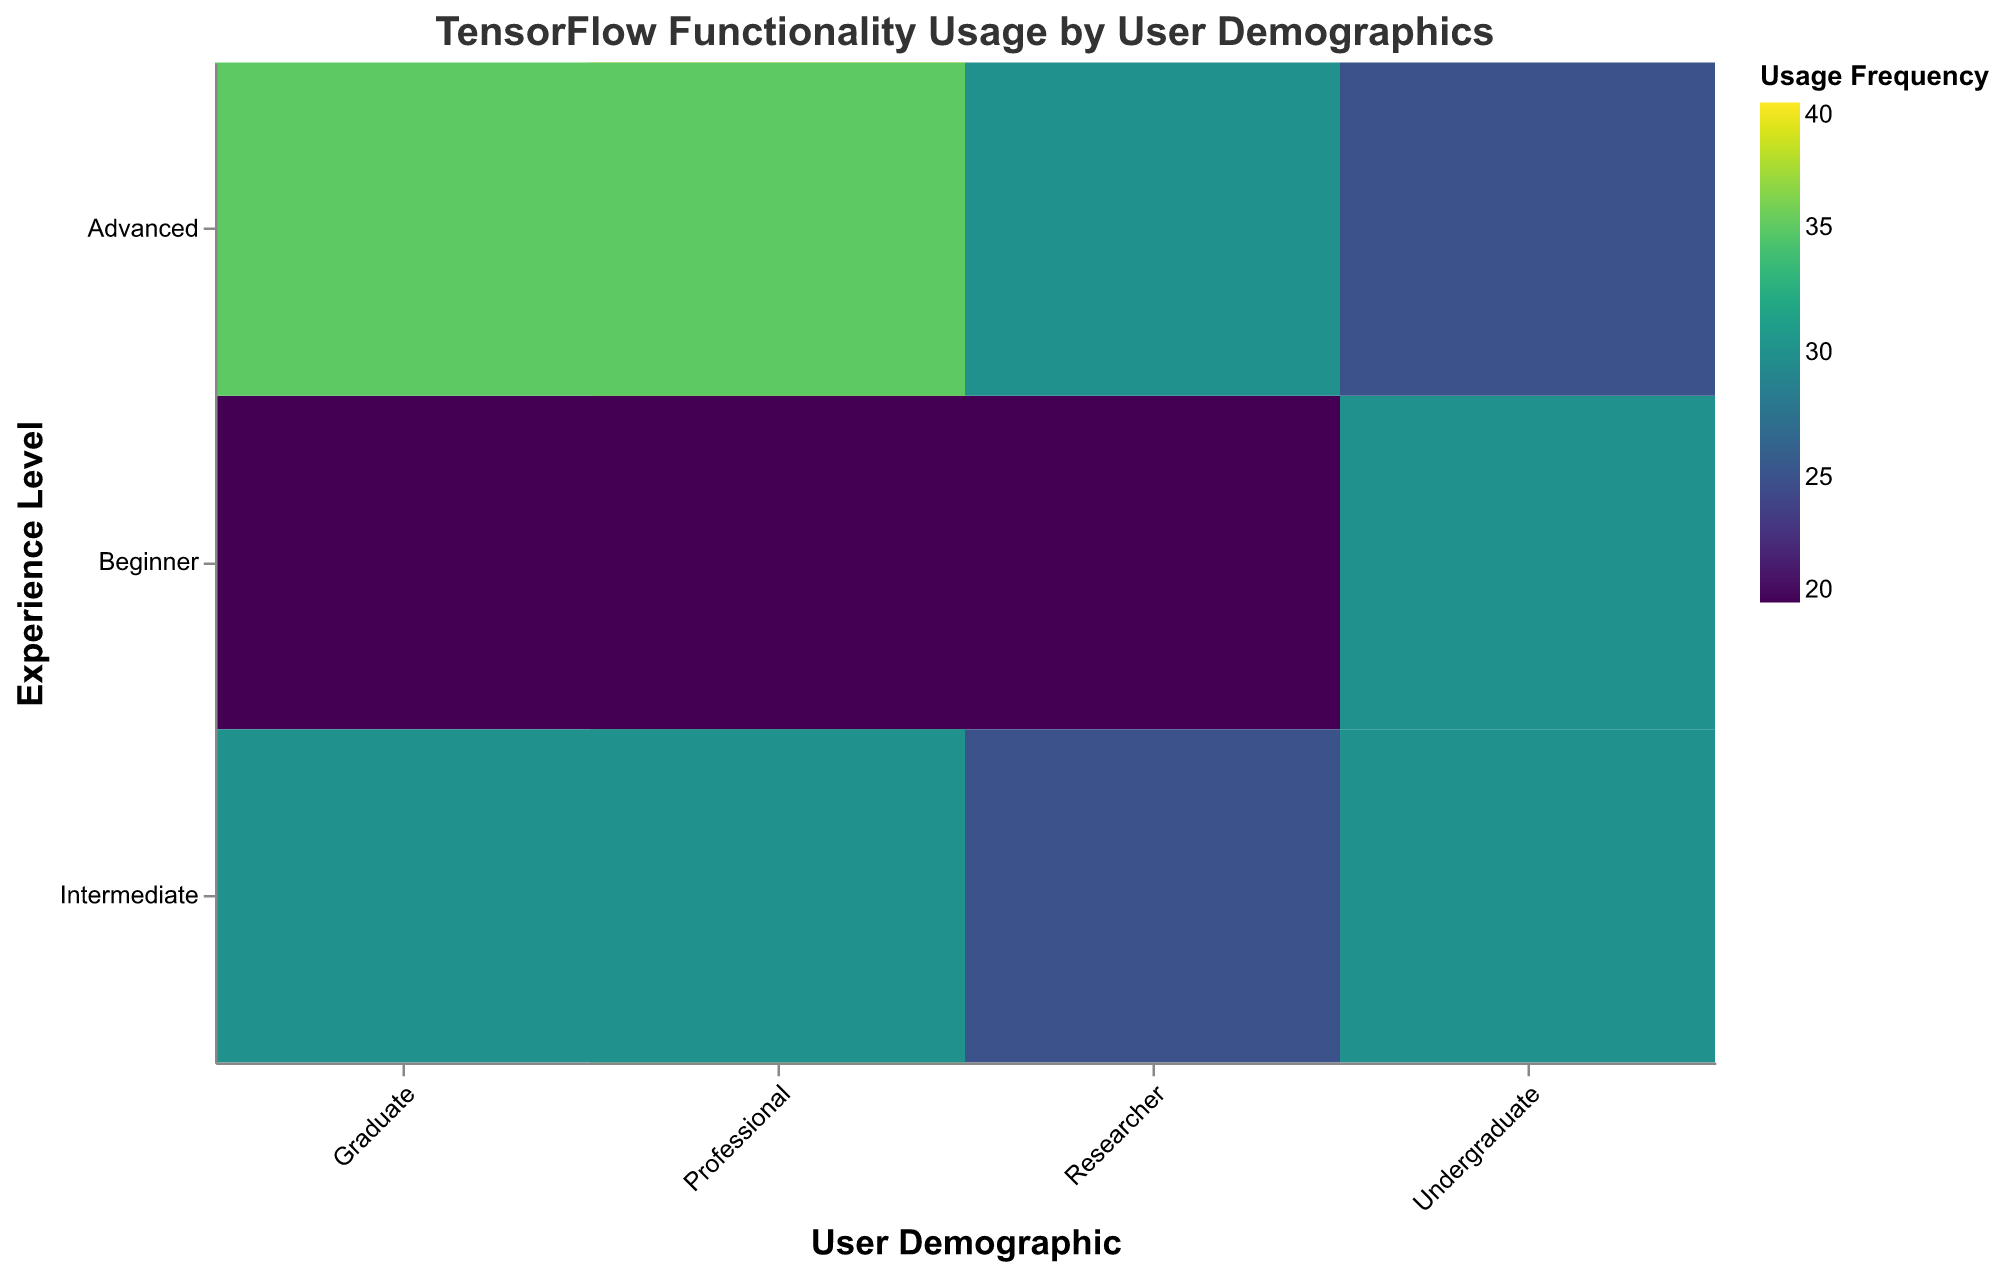What does the title of the heatmap indicate? The title of the heatmap is "TensorFlow Functionality Usage by User Demographics", which indicates that the heatmap visualizes how different functionalities and APIs of TensorFlow are used by various user groups categorized by demographics, experience levels, and project types.
Answer: TensorFlow Functionality Usage by User Demographics Which user demographic and experience level has the highest usage frequency for "Data Loading and Preprocessing"? The color intensity in the heatmap for "Data Loading and Preprocessing" is highest for "Professional" users with "Advanced" experience. This corresponds to the value of 40.
Answer: Professional, Advanced Compare the usage frequency of "Model Training" between "Graduate Advanced NLP Sentiment Analysis" and "Undergraduate Advanced Image Classification". By looking at the tooltip and color gradients in the heatmap, "Graduate Advanced NLP Sentiment Analysis" has a usage frequency of 25 for "Model Training", whereas "Undergraduate Advanced Image Classification" has a frequency of 25. Both are equal.
Answer: Same (25) Which project type and experience level combination has the highest frequency for "Model Deployment"? The darkest color in the heatmap for "Model Deployment" indicates the highest frequency, which is found in "Professional Advanced Time Series Forecasting" with a value of 25.
Answer: Professional, Advanced, Time Series Forecasting What trends can be observed in the increase of functionality usage with the experience level for the "Undergraduate" demographic group? By examining the heatmap, we see that for "Undergraduate" users, as experience level increases from Beginner to Advanced, the usage frequencies for all functionalities generally increase. For instance, "Data Loading and Preprocessing" remains relatively stable at around 30 but "Model Building" increases from 20 to 30, "Model Training" from 15 to 25, "Model Evaluation" from 10 to 25, and "Model Deployment" from 5 to 15.
Answer: Usage increases with experience level Among "Researcher" demographics, which experience level has the most frequent usage of "Model Building" in "Generative Models"? The heatmap shows that among Researchers engaged in Generative Models, "Intermediate" level has the highest frequency of "Model Building" usage with a value of 20.
Answer: Intermediate How does the "Model Evaluation" usage frequency compare between "Professional Intermediate Time Series Forecasting" and "Professional Advanced Recommender Systems"? By comparing the heatmap values, "Professional Intermediate Time Series Forecasting" has a "Model Evaluation" usage frequency of 25, while "Professional Advanced Recommender Systems" has a frequency of 30. The "Advanced Recommender Systems" has a higher usage.
Answer: Higher for Professional Advanced Recommender Systems Identify the project type where "Graduate" users at "Beginner" experience level have minimum usage frequency across all functionalities. The heatmap shows that "Graduate Beginner NLP Sentiment Analysis" has the minimum usage frequency with values of 20 for "Data Loading and Preprocessing", and as low as 10 for other functionalities.
Answer: NLP Sentiment Analysis What is the difference in "Model Building" usage frequency between "Undergraduate Intermediate" and "Professional Beginner"? The tooltip shows that "Undergraduate Intermediate" has "Model Building" usage frequency of 25, whereas "Professional Beginner" has a frequency of 20. Hence the difference is 25 - 20 = 5.
Answer: 5 